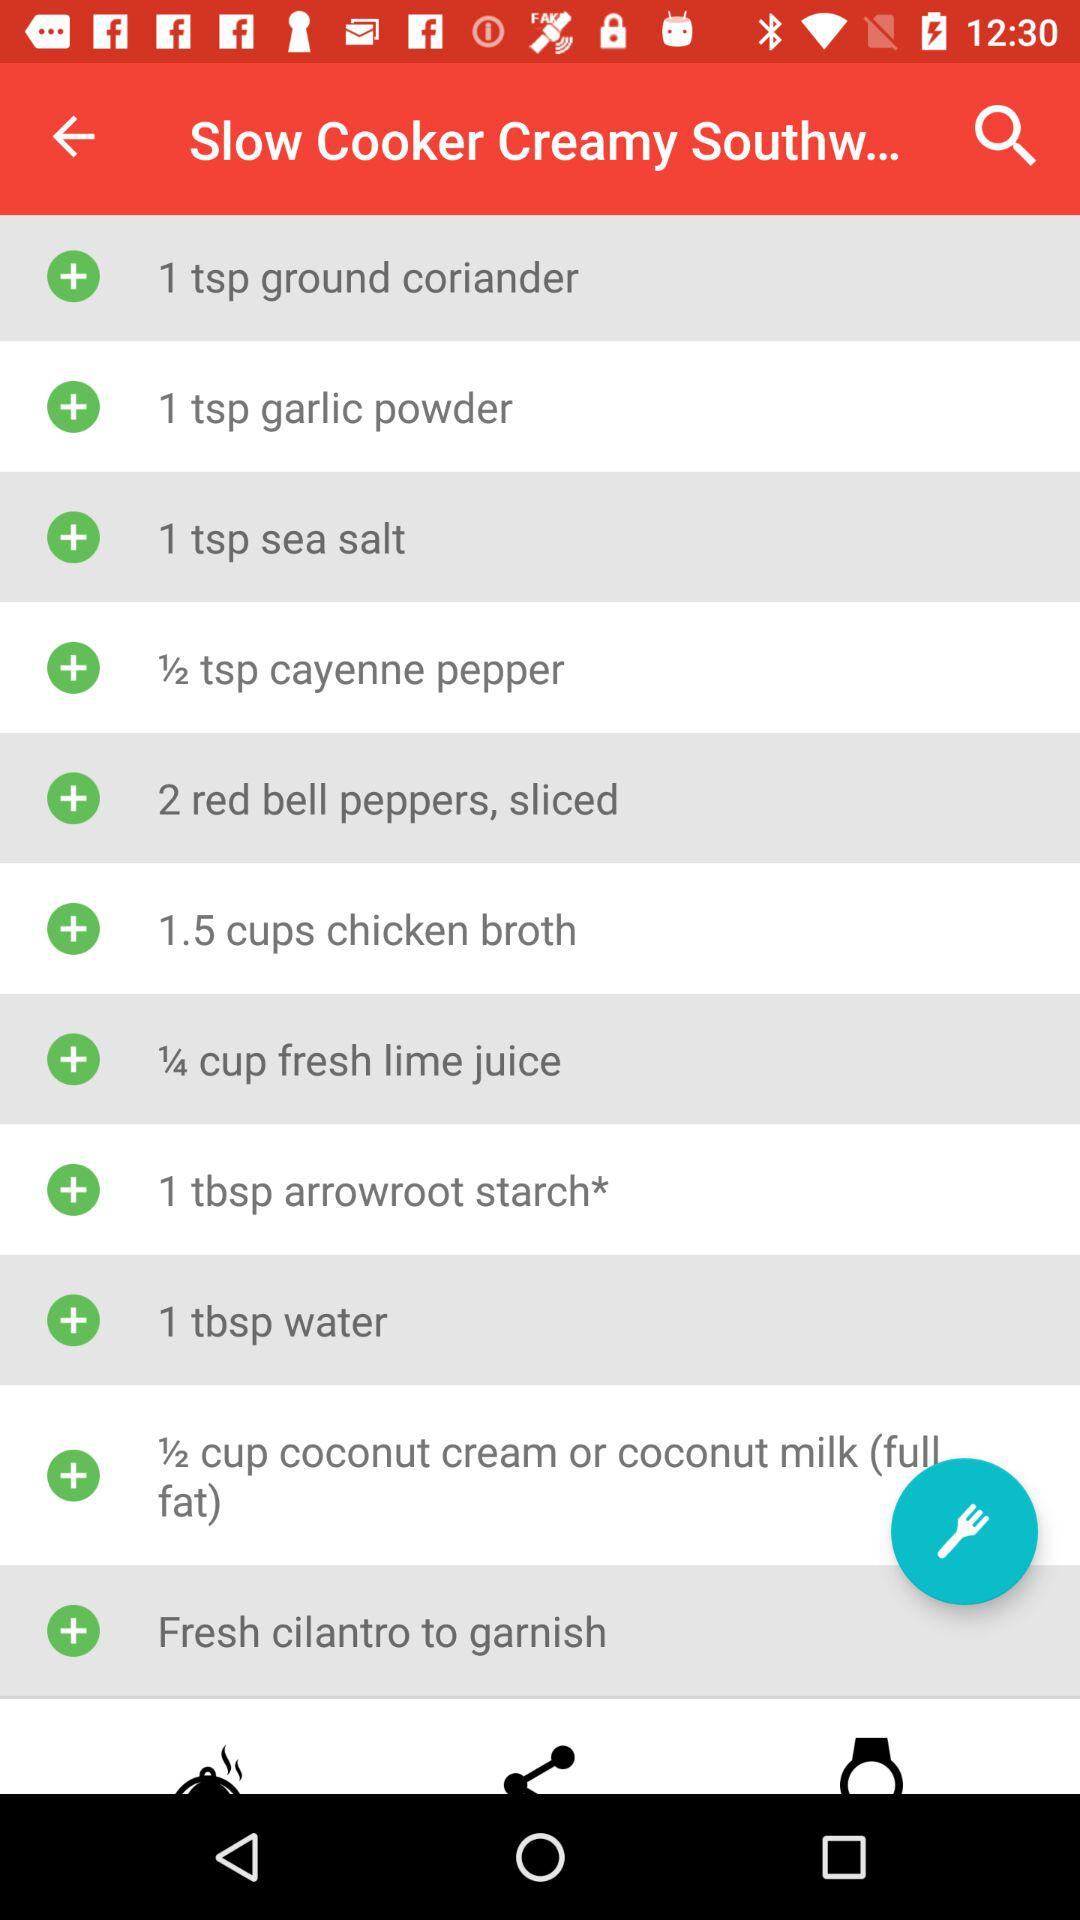How much chicken broth is required? The required quantity of chicken broth is 1.5 cups. 